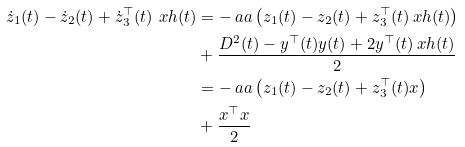<formula> <loc_0><loc_0><loc_500><loc_500>\dot { z } _ { 1 } ( t ) - \dot { z } _ { 2 } ( t ) + \dot { z } _ { 3 } ^ { \top } ( t ) \ x h ( t ) & = - \ a a \left ( z _ { 1 } ( t ) - z _ { 2 } ( t ) + z _ { 3 } ^ { \top } ( t ) \ x h ( t ) \right ) \\ & + \frac { D ^ { 2 } ( t ) - y ^ { \top } ( t ) y ( t ) + 2 y ^ { \top } ( t ) \ x h ( t ) } { 2 } \\ & = - \ a a \left ( z _ { 1 } ( t ) - z _ { 2 } ( t ) + z _ { 3 } ^ { \top } ( t ) x \right ) \\ & + \frac { x ^ { \top } x } { 2 }</formula> 